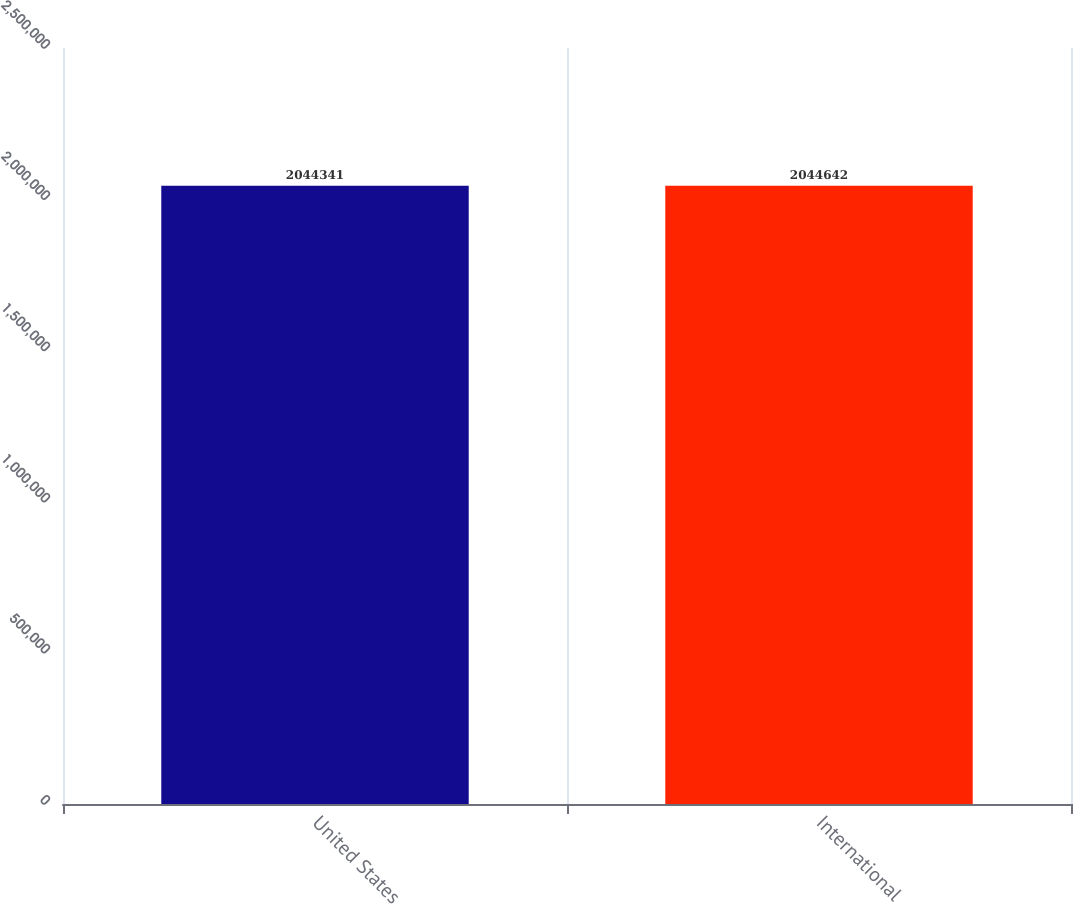<chart> <loc_0><loc_0><loc_500><loc_500><bar_chart><fcel>United States<fcel>International<nl><fcel>2.04434e+06<fcel>2.04464e+06<nl></chart> 